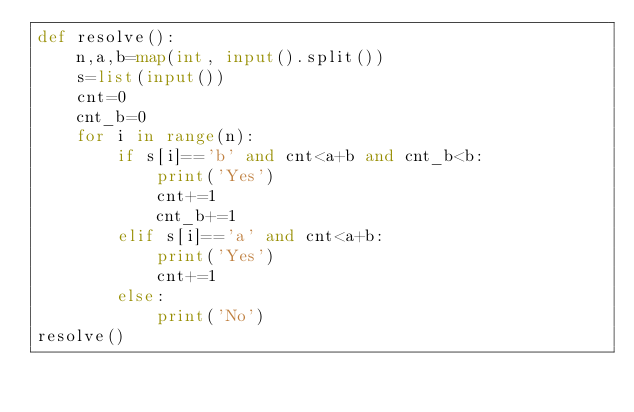<code> <loc_0><loc_0><loc_500><loc_500><_Python_>def resolve():
    n,a,b=map(int, input().split())
    s=list(input())
    cnt=0
    cnt_b=0
    for i in range(n):
        if s[i]=='b' and cnt<a+b and cnt_b<b:
            print('Yes')
            cnt+=1
            cnt_b+=1
        elif s[i]=='a' and cnt<a+b:
            print('Yes')
            cnt+=1
        else:
            print('No')
resolve()</code> 